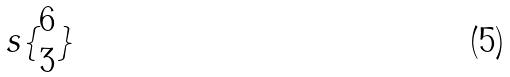<formula> <loc_0><loc_0><loc_500><loc_500>s \{ \begin{matrix} 6 \\ 3 \end{matrix} \}</formula> 